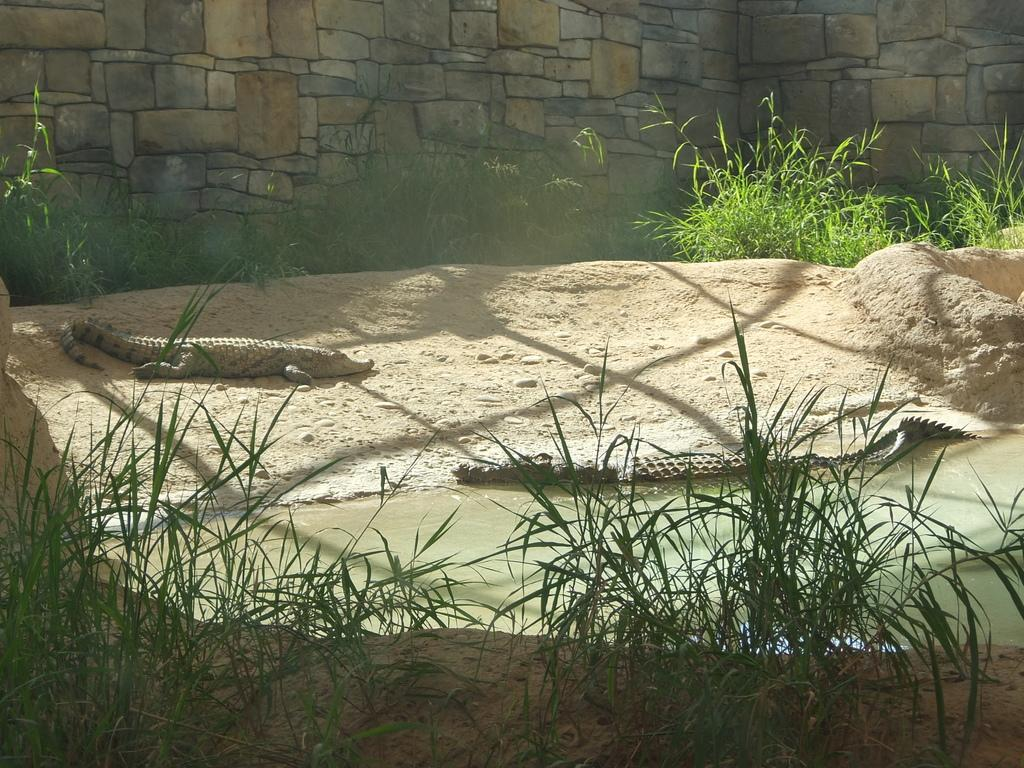What type of vegetation is present in the image? There is grass in the image. How many crocodiles are in the image? There are two crocodiles in the image. Where is one of the crocodiles located? One crocodile is in the water. Where is the other crocodile located? The other crocodile is on the ground. What can be seen in the background of the image? There is a wall in the background of the image. What type of zipper can be seen on the crocodile in the image? There are no zippers present on the crocodiles in the image. Can you tell me how many giraffes are in the image? There are no giraffes present in the image. 